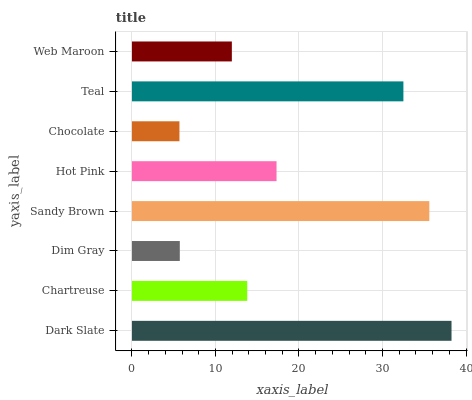Is Chocolate the minimum?
Answer yes or no. Yes. Is Dark Slate the maximum?
Answer yes or no. Yes. Is Chartreuse the minimum?
Answer yes or no. No. Is Chartreuse the maximum?
Answer yes or no. No. Is Dark Slate greater than Chartreuse?
Answer yes or no. Yes. Is Chartreuse less than Dark Slate?
Answer yes or no. Yes. Is Chartreuse greater than Dark Slate?
Answer yes or no. No. Is Dark Slate less than Chartreuse?
Answer yes or no. No. Is Hot Pink the high median?
Answer yes or no. Yes. Is Chartreuse the low median?
Answer yes or no. Yes. Is Sandy Brown the high median?
Answer yes or no. No. Is Dark Slate the low median?
Answer yes or no. No. 